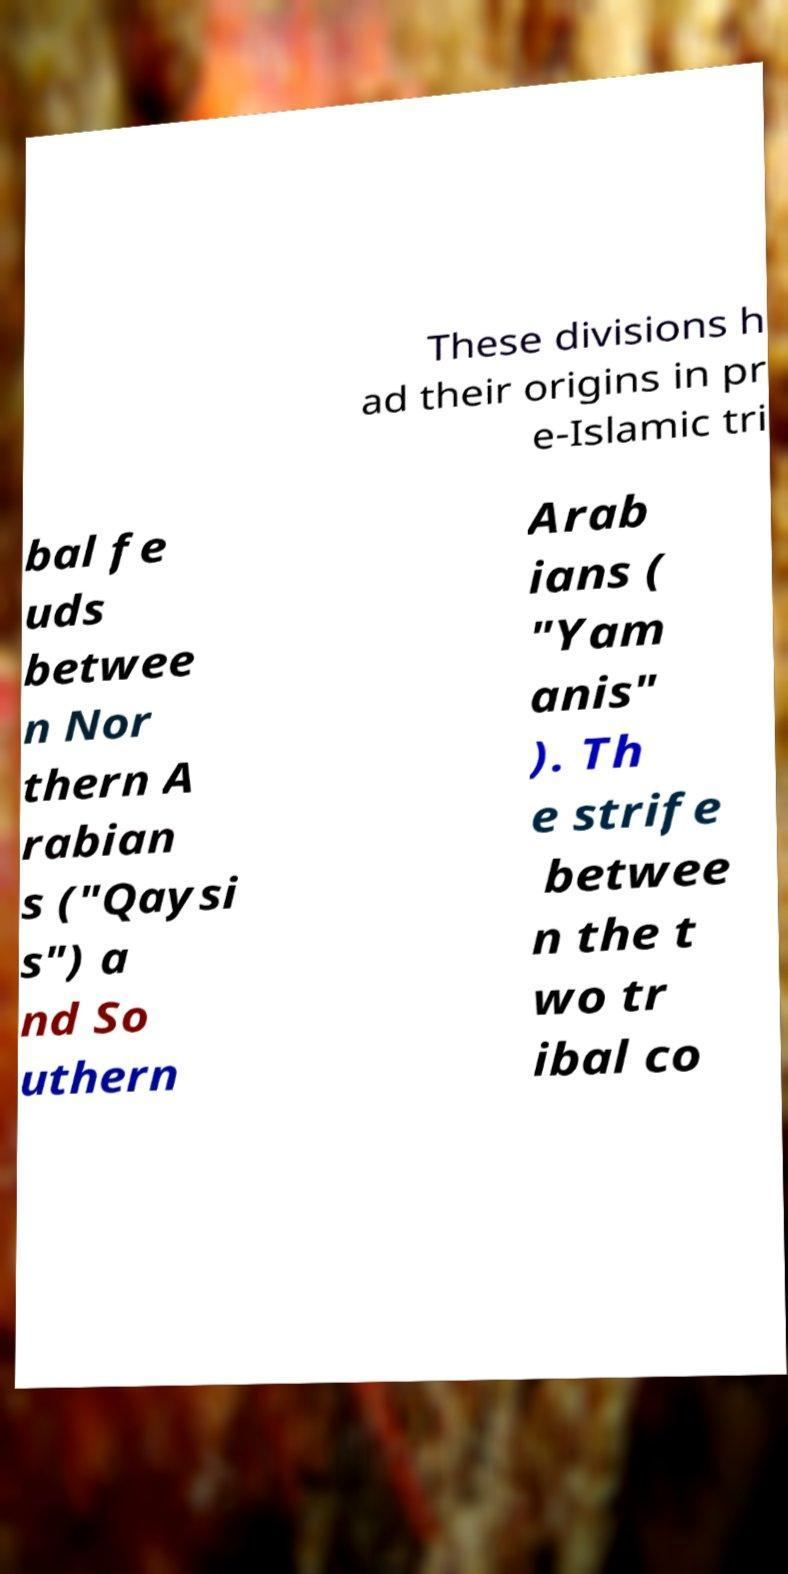Can you read and provide the text displayed in the image?This photo seems to have some interesting text. Can you extract and type it out for me? These divisions h ad their origins in pr e-Islamic tri bal fe uds betwee n Nor thern A rabian s ("Qaysi s") a nd So uthern Arab ians ( "Yam anis" ). Th e strife betwee n the t wo tr ibal co 